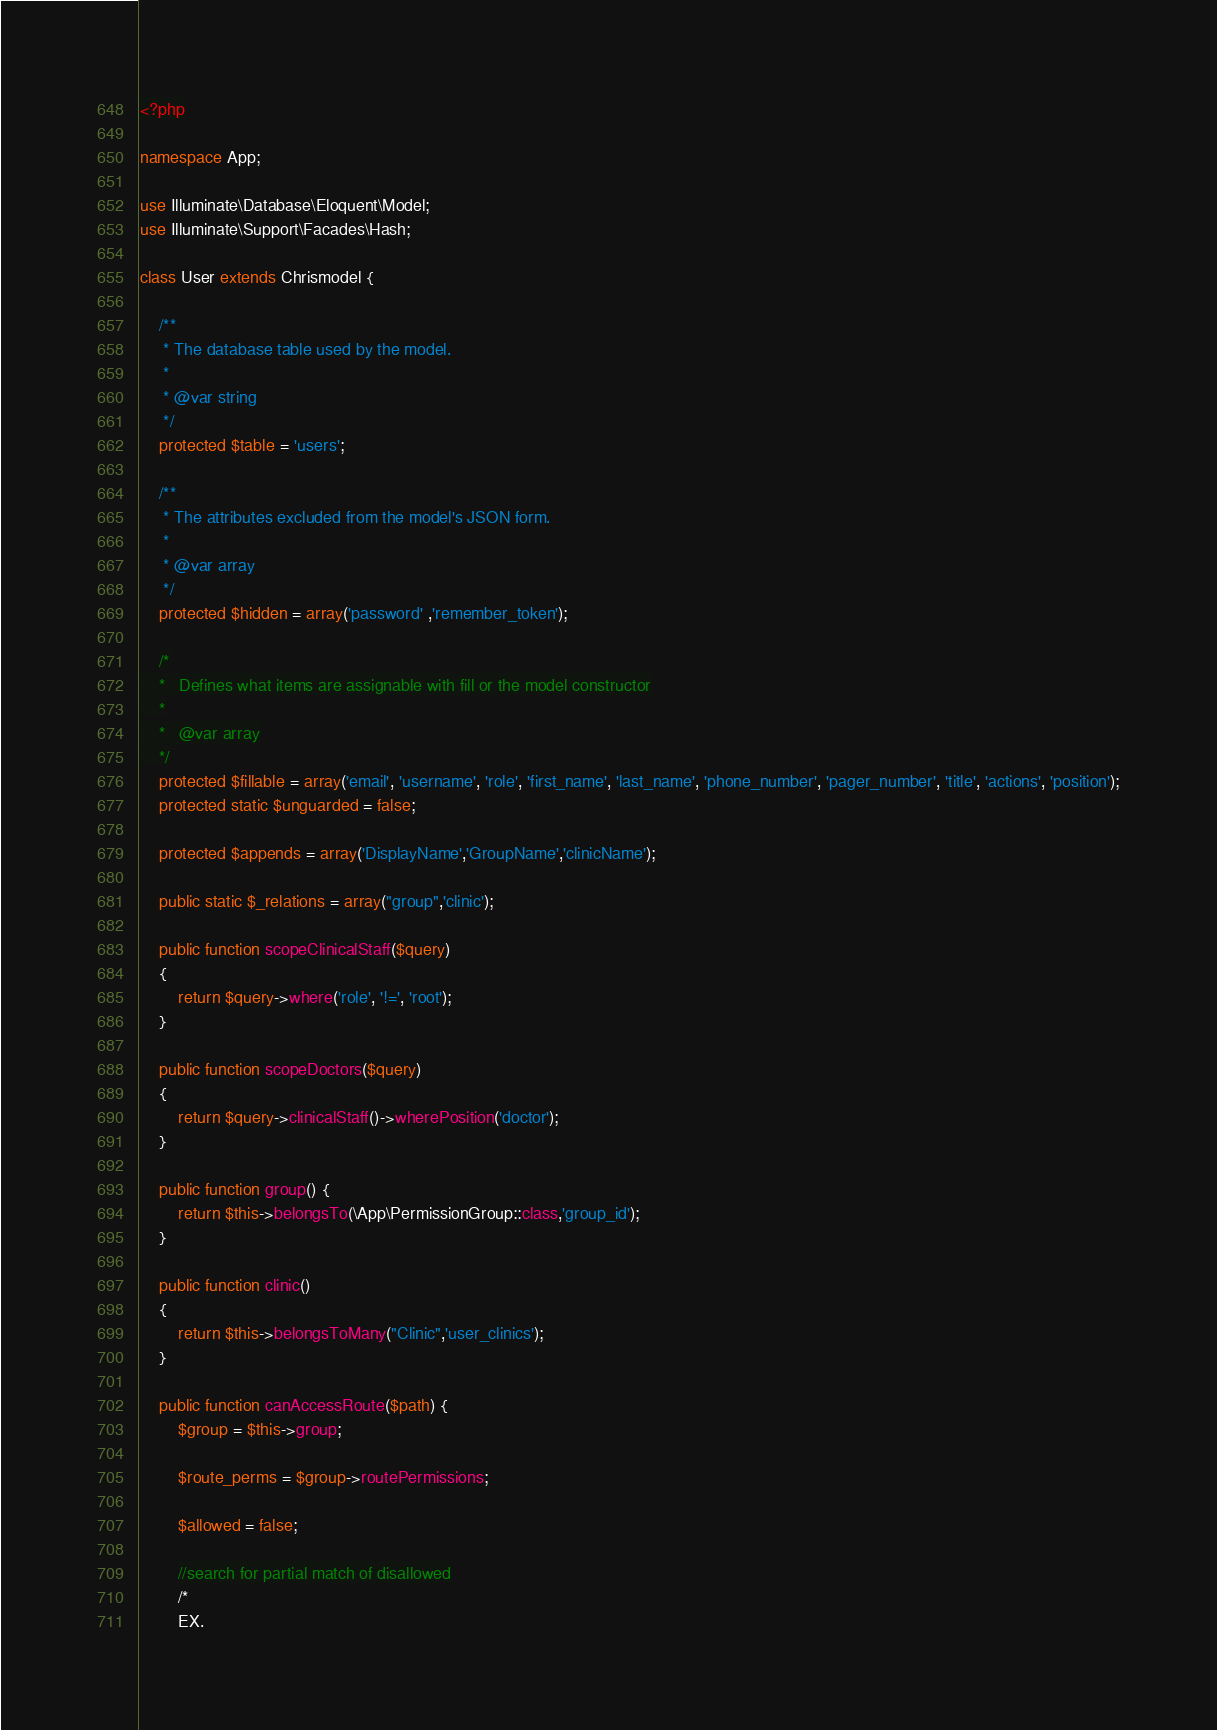<code> <loc_0><loc_0><loc_500><loc_500><_PHP_><?php

namespace App;

use Illuminate\Database\Eloquent\Model;
use Illuminate\Support\Facades\Hash;

class User extends Chrismodel {

	/**
	 * The database table used by the model.
	 *
	 * @var string
	 */
	protected $table = 'users';

	/**
	 * The attributes excluded from the model's JSON form.
	 *
	 * @var array
	 */
	protected $hidden = array('password' ,'remember_token');

	/*
	*	Defines what items are assignable with fill or the model constructor
	*
	*	@var array
	*/
	protected $fillable = array('email', 'username', 'role', 'first_name', 'last_name', 'phone_number', 'pager_number', 'title', 'actions', 'position');
	protected static $unguarded = false;

	protected $appends = array('DisplayName','GroupName','clinicName');

	public static $_relations = array("group",'clinic');
	
	public function scopeClinicalStaff($query)
	{
		return $query->where('role', '!=', 'root');
	}

	public function scopeDoctors($query)
	{
		return $query->clinicalStaff()->wherePosition('doctor');
	}

	public function group() {
		return $this->belongsTo(\App\PermissionGroup::class,'group_id');
	}

	public function clinic()
	{
		return $this->belongsToMany("Clinic",'user_clinics');
	}

	public function canAccessRoute($path) {
		$group = $this->group;

		$route_perms = $group->routePermissions;

		$allowed = false;

		//search for partial match of disallowed
		/*
		EX.</code> 